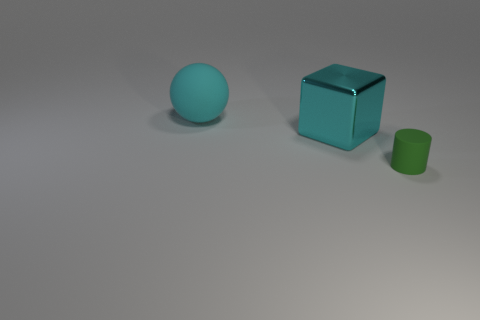Add 3 cyan matte cylinders. How many objects exist? 6 Subtract all blocks. How many objects are left? 2 Add 3 green rubber objects. How many green rubber objects are left? 4 Add 2 large red metal cylinders. How many large red metal cylinders exist? 2 Subtract 0 purple blocks. How many objects are left? 3 Subtract all big cyan metallic blocks. Subtract all tiny green objects. How many objects are left? 1 